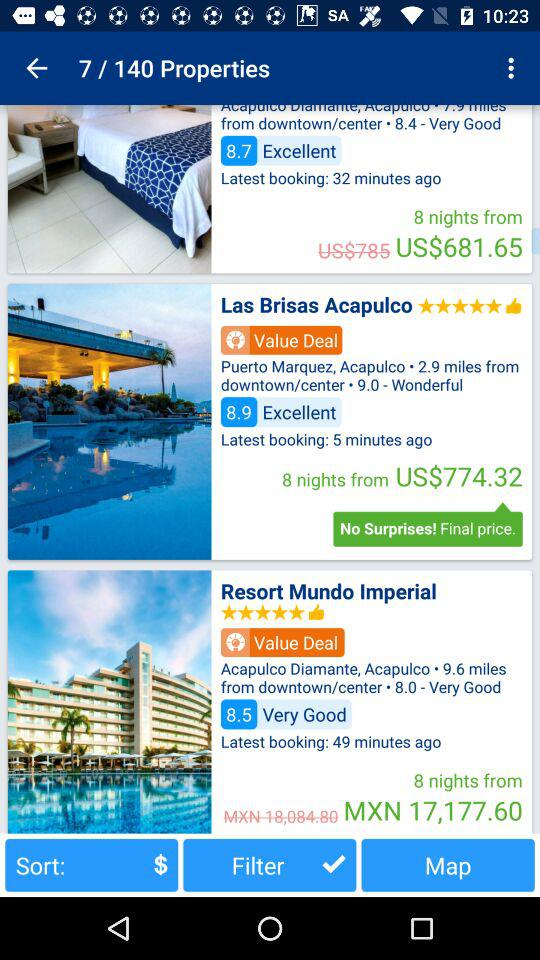When was the latest booking for "Las Brisas Acapulco" made? The latest booking for "Las Brisas Acapulco" was made 5 minutes ago. 